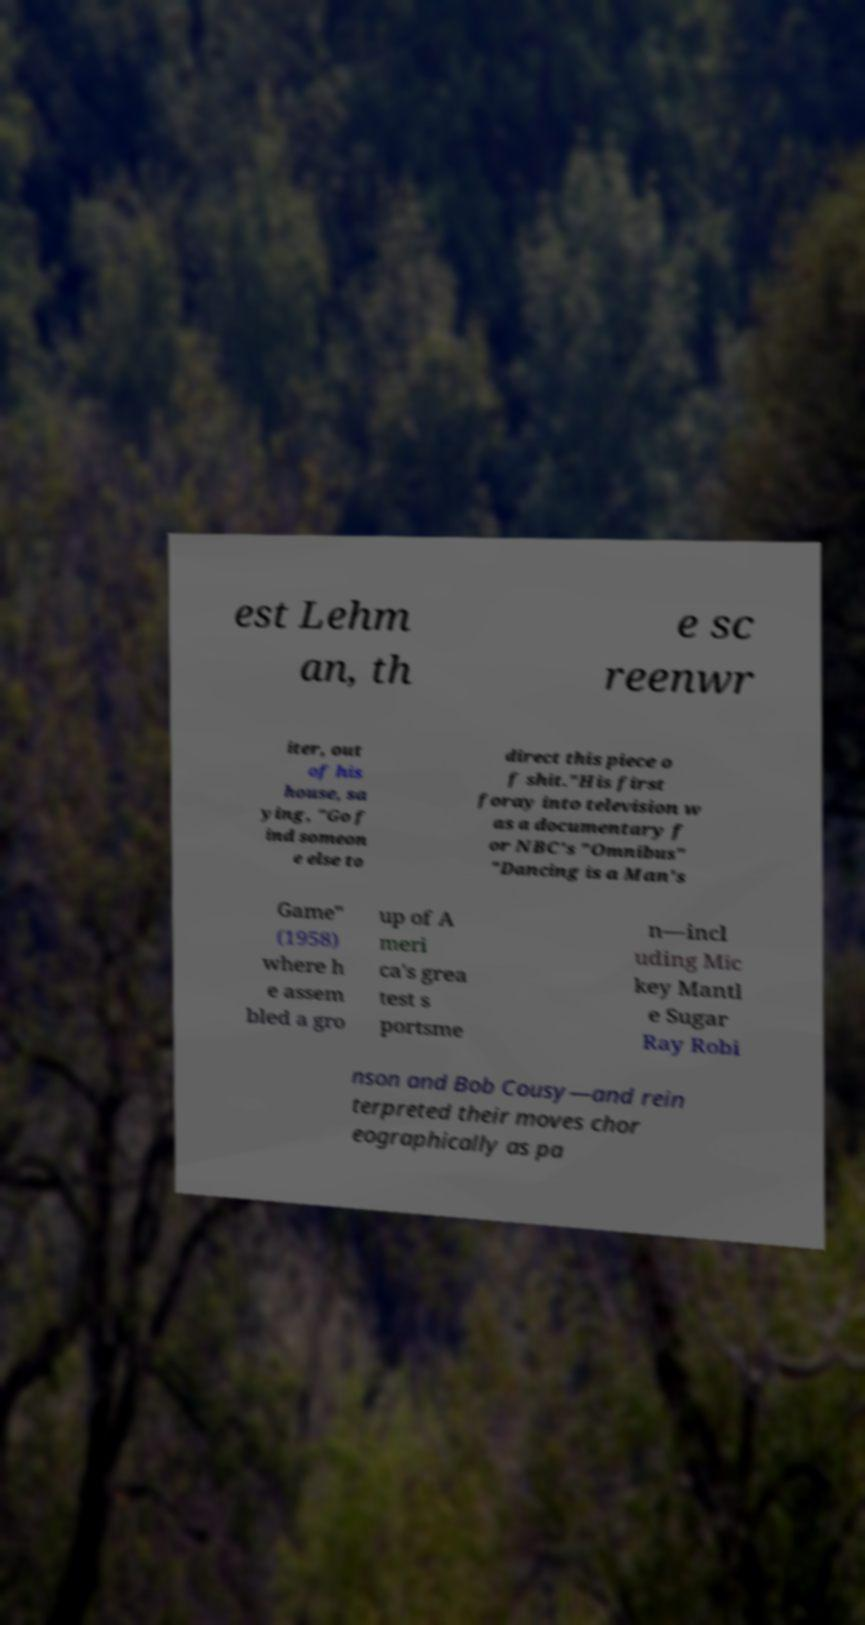I need the written content from this picture converted into text. Can you do that? est Lehm an, th e sc reenwr iter, out of his house, sa ying, "Go f ind someon e else to direct this piece o f shit."His first foray into television w as a documentary f or NBC's "Omnibus" "Dancing is a Man's Game" (1958) where h e assem bled a gro up of A meri ca's grea test s portsme n—incl uding Mic key Mantl e Sugar Ray Robi nson and Bob Cousy—and rein terpreted their moves chor eographically as pa 